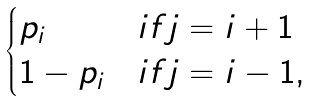Convert formula to latex. <formula><loc_0><loc_0><loc_500><loc_500>\begin{cases} p _ { i } & i f j = i + 1 \\ 1 - p _ { i } & i f j = i - 1 , \\ \end{cases}</formula> 